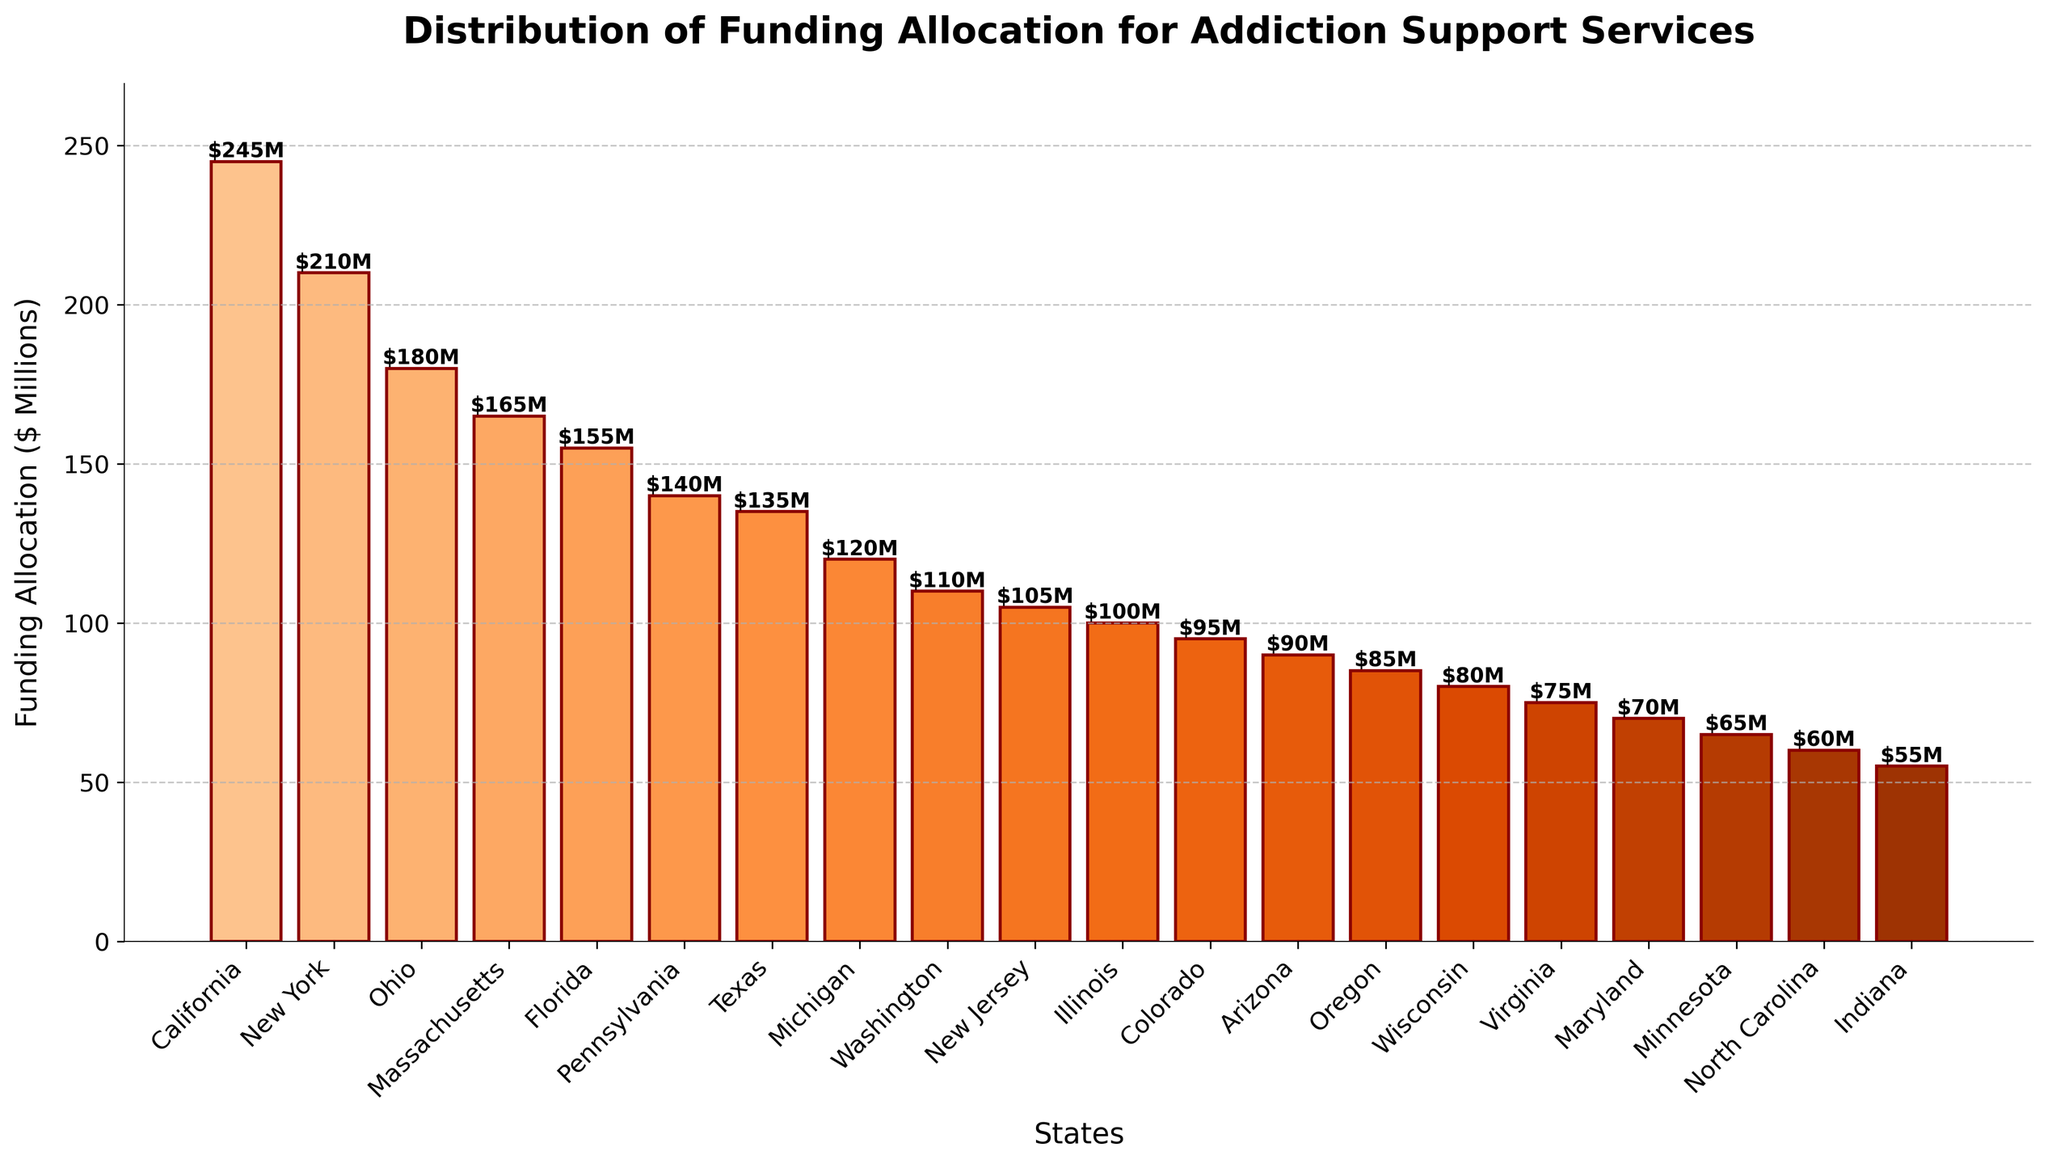What state has the highest funding allocation for addiction support services? The state with the highest bar represents the highest funding. California's bar is the tallest, indicating the highest funding allocation.
Answer: California Which states have funding allocations greater than $200 million? The bars higher than the $200M mark on the y-axis indicate states with funding allocations over $200 million. California and New York have funding allocations greater than $200 million.
Answer: California, New York How much more funding does California receive compared to Florida? Find the heights of the bars for California and Florida and subtract Florida's height from California's height. California gets $245 million, and Florida gets $155 million, so the difference is $245M - $155M = $90M.
Answer: $90 million Which state has a lower funding allocation, Texas or Michigan? Compare the heights of the bars for Texas and Michigan. Texas has a higher bar than Michigan, indicating it has more funding.
Answer: Michigan What is the total funding allocation for Massachusetts, Florida, and Pennsylvania combined? Add the heights of the bars for Massachusetts, Florida, and Pennsylvania. Massachusetts ($165M) + Florida ($155M) + Pennsylvania ($140M) = $460M
Answer: $460 million What is the average funding allocation for the top five states with the highest funding? Sum the heights of the bars for the top five states and divide by five. The top five states are California ($245M), New York ($210M), Ohio ($180M), Massachusetts ($165M), and Florida ($155M). Total is $955M, and the average is $955M / 5 = $191M.
Answer: $191 million Which state’s funding allocation is closest to the median value of all states listed? First, list the funding allocations in ascending order, find the middle value(s) to determine the median. The sorted values are [$55M, $60M, $65M, ..., $245M]. The median value for 20 states is the average of the 10th and 11th values, which are New Jersey ($105M) and Illinois ($100M); the median is ($105M + $100M) / 2 = $102.5M.
Answer: New Jersey How many states have funding allocations between $100 million and $150 million? Count the number of bars with heights between the $100M and $150M marks on the y-axis. New Jersey, Illinois, Colorado, Arizona, Oregon, and Wisconsin fall between $100M and $150M.
Answer: 6 Which state has exactly $100 million allocated for addiction support services? Identify the bar labeled with exactly $100M. Illinois has a bar height of exactly $100M.
Answer: Illinois How does the funding allocation for Washington compare to that of New Jersey? Compare the heights of Washington's and New Jersey's bars. Washington has a $110M allocation, which is higher than New Jersey's $105M allocation.
Answer: Washington has more 